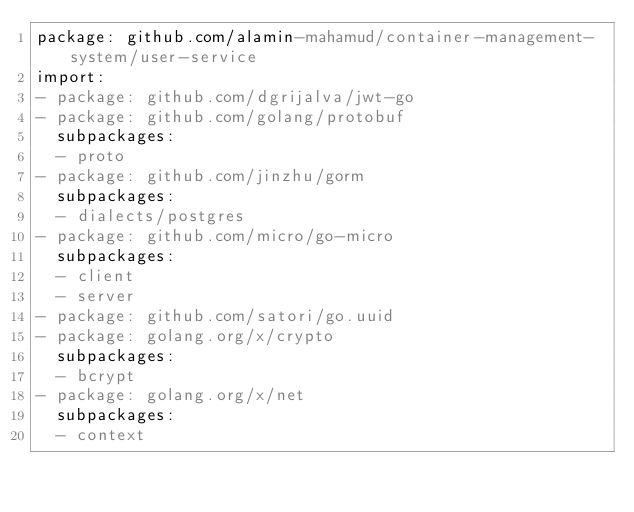<code> <loc_0><loc_0><loc_500><loc_500><_YAML_>package: github.com/alamin-mahamud/container-management-system/user-service
import:
- package: github.com/dgrijalva/jwt-go
- package: github.com/golang/protobuf
  subpackages:
  - proto
- package: github.com/jinzhu/gorm
  subpackages:
  - dialects/postgres
- package: github.com/micro/go-micro
  subpackages:
  - client
  - server
- package: github.com/satori/go.uuid
- package: golang.org/x/crypto
  subpackages:
  - bcrypt
- package: golang.org/x/net
  subpackages:
  - context
</code> 